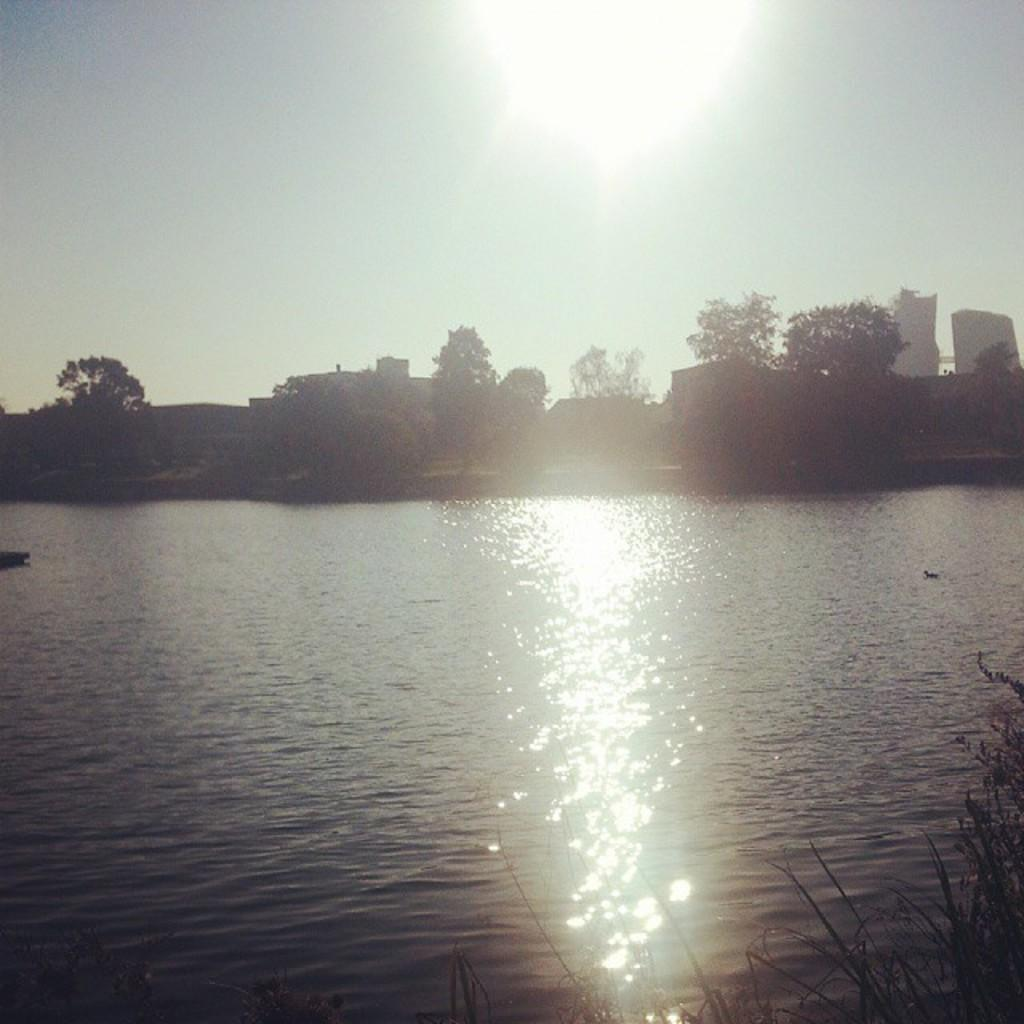What type of structures can be seen in the image? There are buildings in the image. What other natural elements are present in the image? There are plants, a large body of water, and trees in the image. What part of the natural environment is visible in the image? The sky is visible in the image. What type of nail is being used to hold the science book in the image? There is no nail or science book present in the image. What type of underwear is visible on the trees in the image? There is no underwear present in the image; it features buildings, plants, a large body of water, trees, and the sky. 